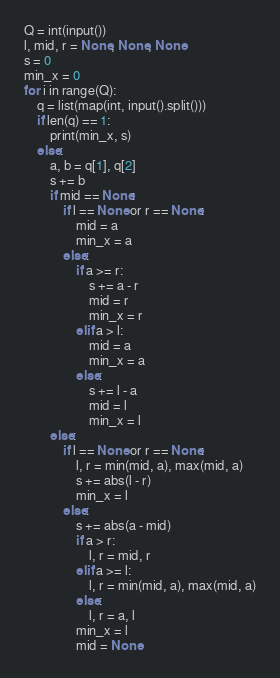<code> <loc_0><loc_0><loc_500><loc_500><_Python_>Q = int(input())
l, mid, r = None, None, None
s = 0
min_x = 0
for i in range(Q):
    q = list(map(int, input().split()))
    if len(q) == 1:
        print(min_x, s)
    else:
        a, b = q[1], q[2]
        s += b
        if mid == None:
            if l == None or r == None:
                mid = a
                min_x = a
            else:
                if a >= r:
                    s += a - r
                    mid = r
                    min_x = r
                elif a > l:
                    mid = a
                    min_x = a
                else:
                    s += l - a
                    mid = l
                    min_x = l
        else:
            if l == None or r == None:
                l, r = min(mid, a), max(mid, a)
                s += abs(l - r)
                min_x = l
            else:
                s += abs(a - mid)
                if a > r:
                    l, r = mid, r
                elif a >= l:
                    l, r = min(mid, a), max(mid, a)
                else:
                    l, r = a, l
                min_x = l
                mid = None</code> 